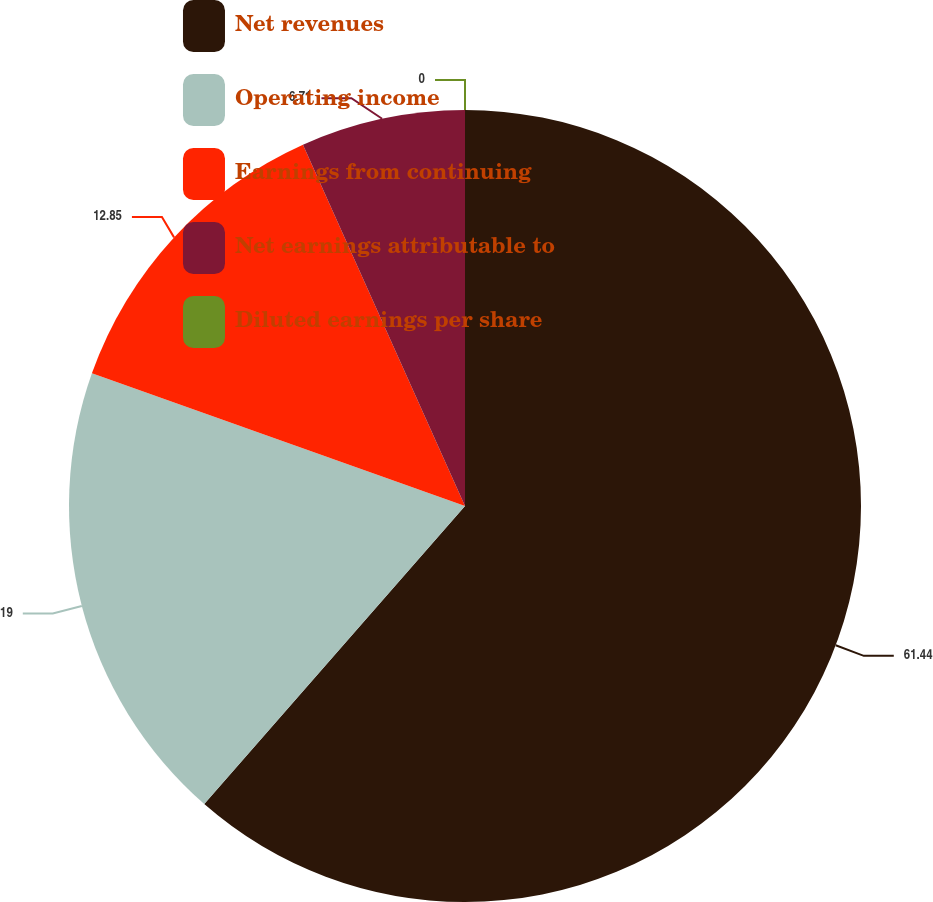Convert chart. <chart><loc_0><loc_0><loc_500><loc_500><pie_chart><fcel>Net revenues<fcel>Operating income<fcel>Earnings from continuing<fcel>Net earnings attributable to<fcel>Diluted earnings per share<nl><fcel>61.44%<fcel>19.0%<fcel>12.85%<fcel>6.71%<fcel>0.0%<nl></chart> 